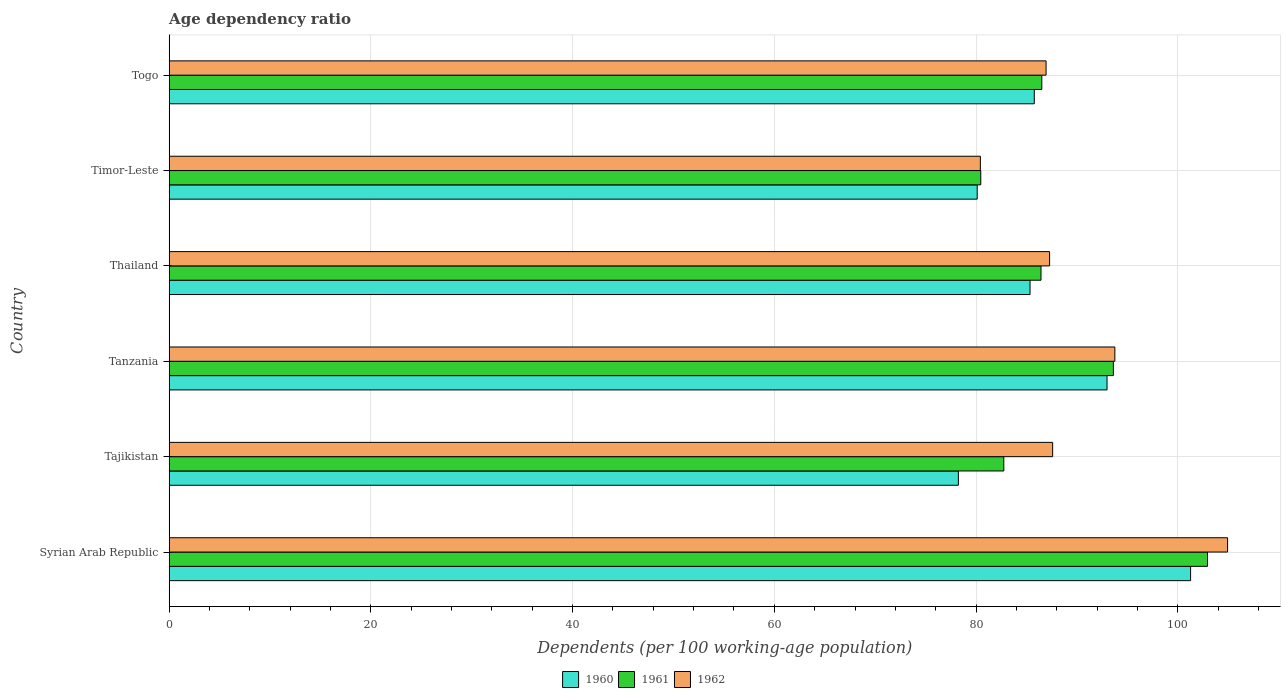How many groups of bars are there?
Ensure brevity in your answer.  6. Are the number of bars per tick equal to the number of legend labels?
Give a very brief answer. Yes. What is the label of the 1st group of bars from the top?
Your answer should be very brief. Togo. What is the age dependency ratio in in 1962 in Tanzania?
Offer a terse response. 93.77. Across all countries, what is the maximum age dependency ratio in in 1962?
Offer a very short reply. 104.94. Across all countries, what is the minimum age dependency ratio in in 1961?
Your response must be concise. 80.47. In which country was the age dependency ratio in in 1960 maximum?
Ensure brevity in your answer.  Syrian Arab Republic. In which country was the age dependency ratio in in 1962 minimum?
Offer a terse response. Timor-Leste. What is the total age dependency ratio in in 1961 in the graph?
Provide a succinct answer. 532.76. What is the difference between the age dependency ratio in in 1962 in Tajikistan and that in Tanzania?
Offer a terse response. -6.17. What is the difference between the age dependency ratio in in 1961 in Togo and the age dependency ratio in in 1960 in Timor-Leste?
Provide a succinct answer. 6.41. What is the average age dependency ratio in in 1962 per country?
Offer a very short reply. 90.16. What is the difference between the age dependency ratio in in 1962 and age dependency ratio in in 1960 in Togo?
Provide a succinct answer. 1.17. What is the ratio of the age dependency ratio in in 1961 in Tajikistan to that in Togo?
Ensure brevity in your answer.  0.96. Is the age dependency ratio in in 1961 in Syrian Arab Republic less than that in Thailand?
Offer a very short reply. No. Is the difference between the age dependency ratio in in 1962 in Tajikistan and Tanzania greater than the difference between the age dependency ratio in in 1960 in Tajikistan and Tanzania?
Offer a terse response. Yes. What is the difference between the highest and the second highest age dependency ratio in in 1961?
Offer a very short reply. 9.33. What is the difference between the highest and the lowest age dependency ratio in in 1961?
Ensure brevity in your answer.  22.48. Is it the case that in every country, the sum of the age dependency ratio in in 1962 and age dependency ratio in in 1961 is greater than the age dependency ratio in in 1960?
Make the answer very short. Yes. Does the graph contain any zero values?
Give a very brief answer. No. Does the graph contain grids?
Offer a terse response. Yes. Where does the legend appear in the graph?
Your answer should be compact. Bottom center. How many legend labels are there?
Your answer should be compact. 3. What is the title of the graph?
Give a very brief answer. Age dependency ratio. Does "1979" appear as one of the legend labels in the graph?
Make the answer very short. No. What is the label or title of the X-axis?
Offer a terse response. Dependents (per 100 working-age population). What is the Dependents (per 100 working-age population) in 1960 in Syrian Arab Republic?
Your response must be concise. 101.28. What is the Dependents (per 100 working-age population) of 1961 in Syrian Arab Republic?
Ensure brevity in your answer.  102.95. What is the Dependents (per 100 working-age population) of 1962 in Syrian Arab Republic?
Make the answer very short. 104.94. What is the Dependents (per 100 working-age population) of 1960 in Tajikistan?
Your response must be concise. 78.25. What is the Dependents (per 100 working-age population) of 1961 in Tajikistan?
Offer a very short reply. 82.76. What is the Dependents (per 100 working-age population) of 1962 in Tajikistan?
Your answer should be compact. 87.6. What is the Dependents (per 100 working-age population) in 1960 in Tanzania?
Your response must be concise. 92.99. What is the Dependents (per 100 working-age population) in 1961 in Tanzania?
Ensure brevity in your answer.  93.62. What is the Dependents (per 100 working-age population) of 1962 in Tanzania?
Offer a terse response. 93.77. What is the Dependents (per 100 working-age population) in 1960 in Thailand?
Give a very brief answer. 85.36. What is the Dependents (per 100 working-age population) in 1961 in Thailand?
Give a very brief answer. 86.44. What is the Dependents (per 100 working-age population) in 1962 in Thailand?
Make the answer very short. 87.29. What is the Dependents (per 100 working-age population) in 1960 in Timor-Leste?
Offer a terse response. 80.12. What is the Dependents (per 100 working-age population) in 1961 in Timor-Leste?
Give a very brief answer. 80.47. What is the Dependents (per 100 working-age population) in 1962 in Timor-Leste?
Give a very brief answer. 80.43. What is the Dependents (per 100 working-age population) in 1960 in Togo?
Your answer should be compact. 85.78. What is the Dependents (per 100 working-age population) of 1961 in Togo?
Your answer should be compact. 86.52. What is the Dependents (per 100 working-age population) of 1962 in Togo?
Provide a succinct answer. 86.95. Across all countries, what is the maximum Dependents (per 100 working-age population) in 1960?
Offer a very short reply. 101.28. Across all countries, what is the maximum Dependents (per 100 working-age population) of 1961?
Offer a very short reply. 102.95. Across all countries, what is the maximum Dependents (per 100 working-age population) of 1962?
Make the answer very short. 104.94. Across all countries, what is the minimum Dependents (per 100 working-age population) in 1960?
Make the answer very short. 78.25. Across all countries, what is the minimum Dependents (per 100 working-age population) in 1961?
Your response must be concise. 80.47. Across all countries, what is the minimum Dependents (per 100 working-age population) in 1962?
Your response must be concise. 80.43. What is the total Dependents (per 100 working-age population) of 1960 in the graph?
Provide a succinct answer. 523.76. What is the total Dependents (per 100 working-age population) of 1961 in the graph?
Offer a terse response. 532.76. What is the total Dependents (per 100 working-age population) of 1962 in the graph?
Provide a short and direct response. 540.97. What is the difference between the Dependents (per 100 working-age population) in 1960 in Syrian Arab Republic and that in Tajikistan?
Ensure brevity in your answer.  23.03. What is the difference between the Dependents (per 100 working-age population) in 1961 in Syrian Arab Republic and that in Tajikistan?
Keep it short and to the point. 20.2. What is the difference between the Dependents (per 100 working-age population) of 1962 in Syrian Arab Republic and that in Tajikistan?
Offer a very short reply. 17.35. What is the difference between the Dependents (per 100 working-age population) in 1960 in Syrian Arab Republic and that in Tanzania?
Ensure brevity in your answer.  8.29. What is the difference between the Dependents (per 100 working-age population) in 1961 in Syrian Arab Republic and that in Tanzania?
Ensure brevity in your answer.  9.33. What is the difference between the Dependents (per 100 working-age population) of 1962 in Syrian Arab Republic and that in Tanzania?
Keep it short and to the point. 11.18. What is the difference between the Dependents (per 100 working-age population) in 1960 in Syrian Arab Republic and that in Thailand?
Your answer should be very brief. 15.92. What is the difference between the Dependents (per 100 working-age population) of 1961 in Syrian Arab Republic and that in Thailand?
Your response must be concise. 16.51. What is the difference between the Dependents (per 100 working-age population) in 1962 in Syrian Arab Republic and that in Thailand?
Provide a short and direct response. 17.65. What is the difference between the Dependents (per 100 working-age population) in 1960 in Syrian Arab Republic and that in Timor-Leste?
Give a very brief answer. 21.16. What is the difference between the Dependents (per 100 working-age population) of 1961 in Syrian Arab Republic and that in Timor-Leste?
Your response must be concise. 22.48. What is the difference between the Dependents (per 100 working-age population) in 1962 in Syrian Arab Republic and that in Timor-Leste?
Keep it short and to the point. 24.51. What is the difference between the Dependents (per 100 working-age population) in 1960 in Syrian Arab Republic and that in Togo?
Make the answer very short. 15.5. What is the difference between the Dependents (per 100 working-age population) of 1961 in Syrian Arab Republic and that in Togo?
Your answer should be very brief. 16.43. What is the difference between the Dependents (per 100 working-age population) of 1962 in Syrian Arab Republic and that in Togo?
Make the answer very short. 18. What is the difference between the Dependents (per 100 working-age population) in 1960 in Tajikistan and that in Tanzania?
Give a very brief answer. -14.74. What is the difference between the Dependents (per 100 working-age population) of 1961 in Tajikistan and that in Tanzania?
Provide a short and direct response. -10.86. What is the difference between the Dependents (per 100 working-age population) of 1962 in Tajikistan and that in Tanzania?
Provide a short and direct response. -6.17. What is the difference between the Dependents (per 100 working-age population) in 1960 in Tajikistan and that in Thailand?
Provide a succinct answer. -7.11. What is the difference between the Dependents (per 100 working-age population) of 1961 in Tajikistan and that in Thailand?
Provide a succinct answer. -3.69. What is the difference between the Dependents (per 100 working-age population) of 1962 in Tajikistan and that in Thailand?
Provide a succinct answer. 0.3. What is the difference between the Dependents (per 100 working-age population) of 1960 in Tajikistan and that in Timor-Leste?
Provide a short and direct response. -1.87. What is the difference between the Dependents (per 100 working-age population) of 1961 in Tajikistan and that in Timor-Leste?
Keep it short and to the point. 2.29. What is the difference between the Dependents (per 100 working-age population) of 1962 in Tajikistan and that in Timor-Leste?
Offer a very short reply. 7.17. What is the difference between the Dependents (per 100 working-age population) of 1960 in Tajikistan and that in Togo?
Offer a very short reply. -7.53. What is the difference between the Dependents (per 100 working-age population) in 1961 in Tajikistan and that in Togo?
Offer a terse response. -3.77. What is the difference between the Dependents (per 100 working-age population) of 1962 in Tajikistan and that in Togo?
Make the answer very short. 0.65. What is the difference between the Dependents (per 100 working-age population) in 1960 in Tanzania and that in Thailand?
Ensure brevity in your answer.  7.63. What is the difference between the Dependents (per 100 working-age population) in 1961 in Tanzania and that in Thailand?
Your answer should be compact. 7.18. What is the difference between the Dependents (per 100 working-age population) in 1962 in Tanzania and that in Thailand?
Give a very brief answer. 6.47. What is the difference between the Dependents (per 100 working-age population) in 1960 in Tanzania and that in Timor-Leste?
Your response must be concise. 12.87. What is the difference between the Dependents (per 100 working-age population) in 1961 in Tanzania and that in Timor-Leste?
Your answer should be very brief. 13.15. What is the difference between the Dependents (per 100 working-age population) of 1962 in Tanzania and that in Timor-Leste?
Offer a very short reply. 13.34. What is the difference between the Dependents (per 100 working-age population) of 1960 in Tanzania and that in Togo?
Provide a short and direct response. 7.21. What is the difference between the Dependents (per 100 working-age population) of 1961 in Tanzania and that in Togo?
Keep it short and to the point. 7.1. What is the difference between the Dependents (per 100 working-age population) in 1962 in Tanzania and that in Togo?
Your response must be concise. 6.82. What is the difference between the Dependents (per 100 working-age population) of 1960 in Thailand and that in Timor-Leste?
Your answer should be very brief. 5.24. What is the difference between the Dependents (per 100 working-age population) of 1961 in Thailand and that in Timor-Leste?
Provide a succinct answer. 5.97. What is the difference between the Dependents (per 100 working-age population) in 1962 in Thailand and that in Timor-Leste?
Offer a terse response. 6.86. What is the difference between the Dependents (per 100 working-age population) in 1960 in Thailand and that in Togo?
Your answer should be very brief. -0.42. What is the difference between the Dependents (per 100 working-age population) in 1961 in Thailand and that in Togo?
Offer a terse response. -0.08. What is the difference between the Dependents (per 100 working-age population) in 1962 in Thailand and that in Togo?
Your response must be concise. 0.35. What is the difference between the Dependents (per 100 working-age population) in 1960 in Timor-Leste and that in Togo?
Make the answer very short. -5.66. What is the difference between the Dependents (per 100 working-age population) of 1961 in Timor-Leste and that in Togo?
Provide a short and direct response. -6.05. What is the difference between the Dependents (per 100 working-age population) in 1962 in Timor-Leste and that in Togo?
Give a very brief answer. -6.52. What is the difference between the Dependents (per 100 working-age population) of 1960 in Syrian Arab Republic and the Dependents (per 100 working-age population) of 1961 in Tajikistan?
Provide a succinct answer. 18.52. What is the difference between the Dependents (per 100 working-age population) of 1960 in Syrian Arab Republic and the Dependents (per 100 working-age population) of 1962 in Tajikistan?
Offer a very short reply. 13.68. What is the difference between the Dependents (per 100 working-age population) of 1961 in Syrian Arab Republic and the Dependents (per 100 working-age population) of 1962 in Tajikistan?
Your answer should be compact. 15.35. What is the difference between the Dependents (per 100 working-age population) in 1960 in Syrian Arab Republic and the Dependents (per 100 working-age population) in 1961 in Tanzania?
Make the answer very short. 7.66. What is the difference between the Dependents (per 100 working-age population) of 1960 in Syrian Arab Republic and the Dependents (per 100 working-age population) of 1962 in Tanzania?
Give a very brief answer. 7.51. What is the difference between the Dependents (per 100 working-age population) in 1961 in Syrian Arab Republic and the Dependents (per 100 working-age population) in 1962 in Tanzania?
Ensure brevity in your answer.  9.19. What is the difference between the Dependents (per 100 working-age population) in 1960 in Syrian Arab Republic and the Dependents (per 100 working-age population) in 1961 in Thailand?
Ensure brevity in your answer.  14.83. What is the difference between the Dependents (per 100 working-age population) of 1960 in Syrian Arab Republic and the Dependents (per 100 working-age population) of 1962 in Thailand?
Ensure brevity in your answer.  13.98. What is the difference between the Dependents (per 100 working-age population) of 1961 in Syrian Arab Republic and the Dependents (per 100 working-age population) of 1962 in Thailand?
Your answer should be compact. 15.66. What is the difference between the Dependents (per 100 working-age population) in 1960 in Syrian Arab Republic and the Dependents (per 100 working-age population) in 1961 in Timor-Leste?
Make the answer very short. 20.8. What is the difference between the Dependents (per 100 working-age population) of 1960 in Syrian Arab Republic and the Dependents (per 100 working-age population) of 1962 in Timor-Leste?
Give a very brief answer. 20.85. What is the difference between the Dependents (per 100 working-age population) of 1961 in Syrian Arab Republic and the Dependents (per 100 working-age population) of 1962 in Timor-Leste?
Your answer should be compact. 22.52. What is the difference between the Dependents (per 100 working-age population) of 1960 in Syrian Arab Republic and the Dependents (per 100 working-age population) of 1961 in Togo?
Provide a succinct answer. 14.75. What is the difference between the Dependents (per 100 working-age population) in 1960 in Syrian Arab Republic and the Dependents (per 100 working-age population) in 1962 in Togo?
Give a very brief answer. 14.33. What is the difference between the Dependents (per 100 working-age population) of 1961 in Syrian Arab Republic and the Dependents (per 100 working-age population) of 1962 in Togo?
Make the answer very short. 16.01. What is the difference between the Dependents (per 100 working-age population) in 1960 in Tajikistan and the Dependents (per 100 working-age population) in 1961 in Tanzania?
Give a very brief answer. -15.37. What is the difference between the Dependents (per 100 working-age population) in 1960 in Tajikistan and the Dependents (per 100 working-age population) in 1962 in Tanzania?
Your answer should be compact. -15.52. What is the difference between the Dependents (per 100 working-age population) in 1961 in Tajikistan and the Dependents (per 100 working-age population) in 1962 in Tanzania?
Your response must be concise. -11.01. What is the difference between the Dependents (per 100 working-age population) in 1960 in Tajikistan and the Dependents (per 100 working-age population) in 1961 in Thailand?
Your answer should be very brief. -8.19. What is the difference between the Dependents (per 100 working-age population) of 1960 in Tajikistan and the Dependents (per 100 working-age population) of 1962 in Thailand?
Offer a very short reply. -9.04. What is the difference between the Dependents (per 100 working-age population) of 1961 in Tajikistan and the Dependents (per 100 working-age population) of 1962 in Thailand?
Keep it short and to the point. -4.54. What is the difference between the Dependents (per 100 working-age population) of 1960 in Tajikistan and the Dependents (per 100 working-age population) of 1961 in Timor-Leste?
Offer a terse response. -2.22. What is the difference between the Dependents (per 100 working-age population) in 1960 in Tajikistan and the Dependents (per 100 working-age population) in 1962 in Timor-Leste?
Ensure brevity in your answer.  -2.18. What is the difference between the Dependents (per 100 working-age population) in 1961 in Tajikistan and the Dependents (per 100 working-age population) in 1962 in Timor-Leste?
Your answer should be compact. 2.33. What is the difference between the Dependents (per 100 working-age population) of 1960 in Tajikistan and the Dependents (per 100 working-age population) of 1961 in Togo?
Provide a succinct answer. -8.27. What is the difference between the Dependents (per 100 working-age population) of 1960 in Tajikistan and the Dependents (per 100 working-age population) of 1962 in Togo?
Your answer should be compact. -8.7. What is the difference between the Dependents (per 100 working-age population) of 1961 in Tajikistan and the Dependents (per 100 working-age population) of 1962 in Togo?
Your answer should be compact. -4.19. What is the difference between the Dependents (per 100 working-age population) in 1960 in Tanzania and the Dependents (per 100 working-age population) in 1961 in Thailand?
Your answer should be very brief. 6.55. What is the difference between the Dependents (per 100 working-age population) of 1960 in Tanzania and the Dependents (per 100 working-age population) of 1962 in Thailand?
Make the answer very short. 5.7. What is the difference between the Dependents (per 100 working-age population) in 1961 in Tanzania and the Dependents (per 100 working-age population) in 1962 in Thailand?
Provide a short and direct response. 6.32. What is the difference between the Dependents (per 100 working-age population) of 1960 in Tanzania and the Dependents (per 100 working-age population) of 1961 in Timor-Leste?
Provide a short and direct response. 12.52. What is the difference between the Dependents (per 100 working-age population) of 1960 in Tanzania and the Dependents (per 100 working-age population) of 1962 in Timor-Leste?
Provide a short and direct response. 12.56. What is the difference between the Dependents (per 100 working-age population) in 1961 in Tanzania and the Dependents (per 100 working-age population) in 1962 in Timor-Leste?
Make the answer very short. 13.19. What is the difference between the Dependents (per 100 working-age population) of 1960 in Tanzania and the Dependents (per 100 working-age population) of 1961 in Togo?
Your answer should be compact. 6.47. What is the difference between the Dependents (per 100 working-age population) of 1960 in Tanzania and the Dependents (per 100 working-age population) of 1962 in Togo?
Provide a short and direct response. 6.04. What is the difference between the Dependents (per 100 working-age population) in 1961 in Tanzania and the Dependents (per 100 working-age population) in 1962 in Togo?
Offer a terse response. 6.67. What is the difference between the Dependents (per 100 working-age population) of 1960 in Thailand and the Dependents (per 100 working-age population) of 1961 in Timor-Leste?
Offer a very short reply. 4.89. What is the difference between the Dependents (per 100 working-age population) of 1960 in Thailand and the Dependents (per 100 working-age population) of 1962 in Timor-Leste?
Make the answer very short. 4.93. What is the difference between the Dependents (per 100 working-age population) of 1961 in Thailand and the Dependents (per 100 working-age population) of 1962 in Timor-Leste?
Provide a short and direct response. 6.01. What is the difference between the Dependents (per 100 working-age population) of 1960 in Thailand and the Dependents (per 100 working-age population) of 1961 in Togo?
Offer a terse response. -1.17. What is the difference between the Dependents (per 100 working-age population) in 1960 in Thailand and the Dependents (per 100 working-age population) in 1962 in Togo?
Your response must be concise. -1.59. What is the difference between the Dependents (per 100 working-age population) of 1961 in Thailand and the Dependents (per 100 working-age population) of 1962 in Togo?
Your answer should be compact. -0.5. What is the difference between the Dependents (per 100 working-age population) in 1960 in Timor-Leste and the Dependents (per 100 working-age population) in 1961 in Togo?
Make the answer very short. -6.41. What is the difference between the Dependents (per 100 working-age population) of 1960 in Timor-Leste and the Dependents (per 100 working-age population) of 1962 in Togo?
Your answer should be compact. -6.83. What is the difference between the Dependents (per 100 working-age population) of 1961 in Timor-Leste and the Dependents (per 100 working-age population) of 1962 in Togo?
Provide a succinct answer. -6.47. What is the average Dependents (per 100 working-age population) of 1960 per country?
Offer a terse response. 87.29. What is the average Dependents (per 100 working-age population) in 1961 per country?
Your answer should be compact. 88.79. What is the average Dependents (per 100 working-age population) in 1962 per country?
Your answer should be compact. 90.16. What is the difference between the Dependents (per 100 working-age population) of 1960 and Dependents (per 100 working-age population) of 1961 in Syrian Arab Republic?
Offer a terse response. -1.68. What is the difference between the Dependents (per 100 working-age population) in 1960 and Dependents (per 100 working-age population) in 1962 in Syrian Arab Republic?
Your answer should be very brief. -3.67. What is the difference between the Dependents (per 100 working-age population) of 1961 and Dependents (per 100 working-age population) of 1962 in Syrian Arab Republic?
Keep it short and to the point. -1.99. What is the difference between the Dependents (per 100 working-age population) in 1960 and Dependents (per 100 working-age population) in 1961 in Tajikistan?
Your answer should be compact. -4.51. What is the difference between the Dependents (per 100 working-age population) in 1960 and Dependents (per 100 working-age population) in 1962 in Tajikistan?
Offer a terse response. -9.35. What is the difference between the Dependents (per 100 working-age population) in 1961 and Dependents (per 100 working-age population) in 1962 in Tajikistan?
Your answer should be very brief. -4.84. What is the difference between the Dependents (per 100 working-age population) in 1960 and Dependents (per 100 working-age population) in 1961 in Tanzania?
Ensure brevity in your answer.  -0.63. What is the difference between the Dependents (per 100 working-age population) in 1960 and Dependents (per 100 working-age population) in 1962 in Tanzania?
Provide a succinct answer. -0.78. What is the difference between the Dependents (per 100 working-age population) in 1961 and Dependents (per 100 working-age population) in 1962 in Tanzania?
Offer a terse response. -0.15. What is the difference between the Dependents (per 100 working-age population) in 1960 and Dependents (per 100 working-age population) in 1961 in Thailand?
Your answer should be very brief. -1.09. What is the difference between the Dependents (per 100 working-age population) in 1960 and Dependents (per 100 working-age population) in 1962 in Thailand?
Give a very brief answer. -1.94. What is the difference between the Dependents (per 100 working-age population) in 1961 and Dependents (per 100 working-age population) in 1962 in Thailand?
Give a very brief answer. -0.85. What is the difference between the Dependents (per 100 working-age population) in 1960 and Dependents (per 100 working-age population) in 1961 in Timor-Leste?
Your answer should be very brief. -0.35. What is the difference between the Dependents (per 100 working-age population) of 1960 and Dependents (per 100 working-age population) of 1962 in Timor-Leste?
Give a very brief answer. -0.31. What is the difference between the Dependents (per 100 working-age population) in 1961 and Dependents (per 100 working-age population) in 1962 in Timor-Leste?
Provide a short and direct response. 0.04. What is the difference between the Dependents (per 100 working-age population) of 1960 and Dependents (per 100 working-age population) of 1961 in Togo?
Keep it short and to the point. -0.74. What is the difference between the Dependents (per 100 working-age population) in 1960 and Dependents (per 100 working-age population) in 1962 in Togo?
Offer a terse response. -1.17. What is the difference between the Dependents (per 100 working-age population) of 1961 and Dependents (per 100 working-age population) of 1962 in Togo?
Keep it short and to the point. -0.42. What is the ratio of the Dependents (per 100 working-age population) in 1960 in Syrian Arab Republic to that in Tajikistan?
Offer a very short reply. 1.29. What is the ratio of the Dependents (per 100 working-age population) in 1961 in Syrian Arab Republic to that in Tajikistan?
Your answer should be compact. 1.24. What is the ratio of the Dependents (per 100 working-age population) of 1962 in Syrian Arab Republic to that in Tajikistan?
Give a very brief answer. 1.2. What is the ratio of the Dependents (per 100 working-age population) in 1960 in Syrian Arab Republic to that in Tanzania?
Give a very brief answer. 1.09. What is the ratio of the Dependents (per 100 working-age population) in 1961 in Syrian Arab Republic to that in Tanzania?
Make the answer very short. 1.1. What is the ratio of the Dependents (per 100 working-age population) in 1962 in Syrian Arab Republic to that in Tanzania?
Provide a succinct answer. 1.12. What is the ratio of the Dependents (per 100 working-age population) of 1960 in Syrian Arab Republic to that in Thailand?
Provide a succinct answer. 1.19. What is the ratio of the Dependents (per 100 working-age population) in 1961 in Syrian Arab Republic to that in Thailand?
Ensure brevity in your answer.  1.19. What is the ratio of the Dependents (per 100 working-age population) of 1962 in Syrian Arab Republic to that in Thailand?
Your answer should be very brief. 1.2. What is the ratio of the Dependents (per 100 working-age population) in 1960 in Syrian Arab Republic to that in Timor-Leste?
Keep it short and to the point. 1.26. What is the ratio of the Dependents (per 100 working-age population) of 1961 in Syrian Arab Republic to that in Timor-Leste?
Offer a terse response. 1.28. What is the ratio of the Dependents (per 100 working-age population) of 1962 in Syrian Arab Republic to that in Timor-Leste?
Provide a short and direct response. 1.3. What is the ratio of the Dependents (per 100 working-age population) of 1960 in Syrian Arab Republic to that in Togo?
Provide a short and direct response. 1.18. What is the ratio of the Dependents (per 100 working-age population) of 1961 in Syrian Arab Republic to that in Togo?
Keep it short and to the point. 1.19. What is the ratio of the Dependents (per 100 working-age population) of 1962 in Syrian Arab Republic to that in Togo?
Offer a very short reply. 1.21. What is the ratio of the Dependents (per 100 working-age population) of 1960 in Tajikistan to that in Tanzania?
Ensure brevity in your answer.  0.84. What is the ratio of the Dependents (per 100 working-age population) in 1961 in Tajikistan to that in Tanzania?
Ensure brevity in your answer.  0.88. What is the ratio of the Dependents (per 100 working-age population) of 1962 in Tajikistan to that in Tanzania?
Offer a very short reply. 0.93. What is the ratio of the Dependents (per 100 working-age population) in 1960 in Tajikistan to that in Thailand?
Give a very brief answer. 0.92. What is the ratio of the Dependents (per 100 working-age population) of 1961 in Tajikistan to that in Thailand?
Keep it short and to the point. 0.96. What is the ratio of the Dependents (per 100 working-age population) in 1960 in Tajikistan to that in Timor-Leste?
Give a very brief answer. 0.98. What is the ratio of the Dependents (per 100 working-age population) of 1961 in Tajikistan to that in Timor-Leste?
Your response must be concise. 1.03. What is the ratio of the Dependents (per 100 working-age population) in 1962 in Tajikistan to that in Timor-Leste?
Provide a short and direct response. 1.09. What is the ratio of the Dependents (per 100 working-age population) in 1960 in Tajikistan to that in Togo?
Make the answer very short. 0.91. What is the ratio of the Dependents (per 100 working-age population) in 1961 in Tajikistan to that in Togo?
Make the answer very short. 0.96. What is the ratio of the Dependents (per 100 working-age population) of 1962 in Tajikistan to that in Togo?
Your answer should be compact. 1.01. What is the ratio of the Dependents (per 100 working-age population) of 1960 in Tanzania to that in Thailand?
Give a very brief answer. 1.09. What is the ratio of the Dependents (per 100 working-age population) in 1961 in Tanzania to that in Thailand?
Offer a very short reply. 1.08. What is the ratio of the Dependents (per 100 working-age population) in 1962 in Tanzania to that in Thailand?
Provide a short and direct response. 1.07. What is the ratio of the Dependents (per 100 working-age population) in 1960 in Tanzania to that in Timor-Leste?
Offer a terse response. 1.16. What is the ratio of the Dependents (per 100 working-age population) in 1961 in Tanzania to that in Timor-Leste?
Make the answer very short. 1.16. What is the ratio of the Dependents (per 100 working-age population) in 1962 in Tanzania to that in Timor-Leste?
Your response must be concise. 1.17. What is the ratio of the Dependents (per 100 working-age population) of 1960 in Tanzania to that in Togo?
Keep it short and to the point. 1.08. What is the ratio of the Dependents (per 100 working-age population) of 1961 in Tanzania to that in Togo?
Offer a very short reply. 1.08. What is the ratio of the Dependents (per 100 working-age population) in 1962 in Tanzania to that in Togo?
Offer a terse response. 1.08. What is the ratio of the Dependents (per 100 working-age population) in 1960 in Thailand to that in Timor-Leste?
Provide a succinct answer. 1.07. What is the ratio of the Dependents (per 100 working-age population) in 1961 in Thailand to that in Timor-Leste?
Give a very brief answer. 1.07. What is the ratio of the Dependents (per 100 working-age population) in 1962 in Thailand to that in Timor-Leste?
Give a very brief answer. 1.09. What is the ratio of the Dependents (per 100 working-age population) in 1961 in Thailand to that in Togo?
Your answer should be very brief. 1. What is the ratio of the Dependents (per 100 working-age population) in 1960 in Timor-Leste to that in Togo?
Provide a succinct answer. 0.93. What is the ratio of the Dependents (per 100 working-age population) of 1962 in Timor-Leste to that in Togo?
Make the answer very short. 0.93. What is the difference between the highest and the second highest Dependents (per 100 working-age population) of 1960?
Your response must be concise. 8.29. What is the difference between the highest and the second highest Dependents (per 100 working-age population) of 1961?
Make the answer very short. 9.33. What is the difference between the highest and the second highest Dependents (per 100 working-age population) in 1962?
Your answer should be very brief. 11.18. What is the difference between the highest and the lowest Dependents (per 100 working-age population) of 1960?
Ensure brevity in your answer.  23.03. What is the difference between the highest and the lowest Dependents (per 100 working-age population) of 1961?
Provide a succinct answer. 22.48. What is the difference between the highest and the lowest Dependents (per 100 working-age population) in 1962?
Keep it short and to the point. 24.51. 